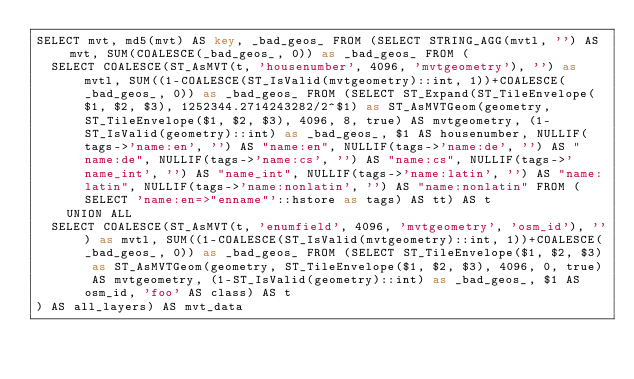Convert code to text. <code><loc_0><loc_0><loc_500><loc_500><_SQL_>SELECT mvt, md5(mvt) AS key, _bad_geos_ FROM (SELECT STRING_AGG(mvtl, '') AS mvt, SUM(COALESCE(_bad_geos_, 0)) as _bad_geos_ FROM (
  SELECT COALESCE(ST_AsMVT(t, 'housenumber', 4096, 'mvtgeometry'), '') as mvtl, SUM((1-COALESCE(ST_IsValid(mvtgeometry)::int, 1))+COALESCE(_bad_geos_, 0)) as _bad_geos_ FROM (SELECT ST_Expand(ST_TileEnvelope($1, $2, $3), 1252344.2714243282/2^$1) as ST_AsMVTGeom(geometry, ST_TileEnvelope($1, $2, $3), 4096, 8, true) AS mvtgeometry, (1-ST_IsValid(geometry)::int) as _bad_geos_, $1 AS housenumber, NULLIF(tags->'name:en', '') AS "name:en", NULLIF(tags->'name:de', '') AS "name:de", NULLIF(tags->'name:cs', '') AS "name:cs", NULLIF(tags->'name_int', '') AS "name_int", NULLIF(tags->'name:latin', '') AS "name:latin", NULLIF(tags->'name:nonlatin', '') AS "name:nonlatin" FROM (SELECT 'name:en=>"enname"'::hstore as tags) AS tt) AS t
    UNION ALL
  SELECT COALESCE(ST_AsMVT(t, 'enumfield', 4096, 'mvtgeometry', 'osm_id'), '') as mvtl, SUM((1-COALESCE(ST_IsValid(mvtgeometry)::int, 1))+COALESCE(_bad_geos_, 0)) as _bad_geos_ FROM (SELECT ST_TileEnvelope($1, $2, $3) as ST_AsMVTGeom(geometry, ST_TileEnvelope($1, $2, $3), 4096, 0, true) AS mvtgeometry, (1-ST_IsValid(geometry)::int) as _bad_geos_, $1 AS osm_id, 'foo' AS class) AS t
) AS all_layers) AS mvt_data

</code> 